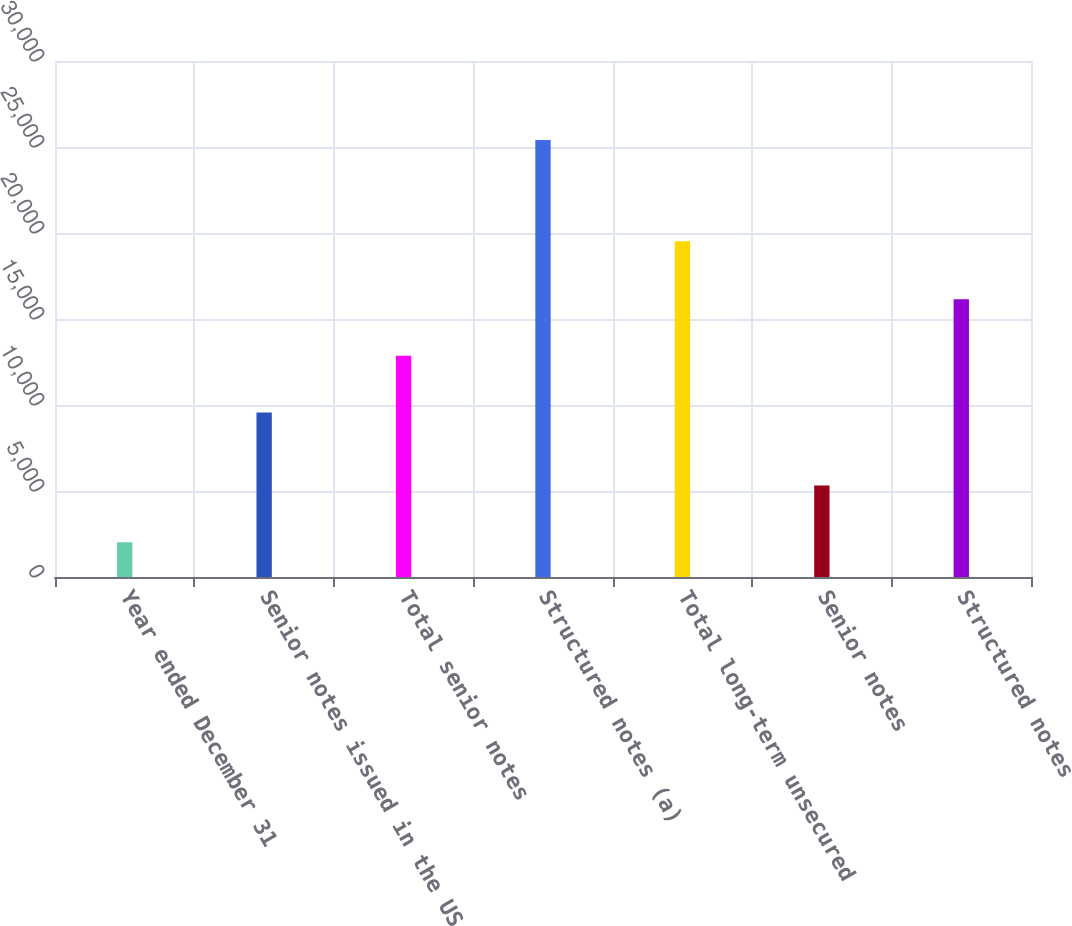Convert chart to OTSL. <chart><loc_0><loc_0><loc_500><loc_500><bar_chart><fcel>Year ended December 31<fcel>Senior notes issued in the US<fcel>Total senior notes<fcel>Structured notes (a)<fcel>Total long-term unsecured<fcel>Senior notes<fcel>Structured notes<nl><fcel>2018<fcel>9562<fcel>12857.4<fcel>25410<fcel>19515<fcel>5313.4<fcel>16152.8<nl></chart> 